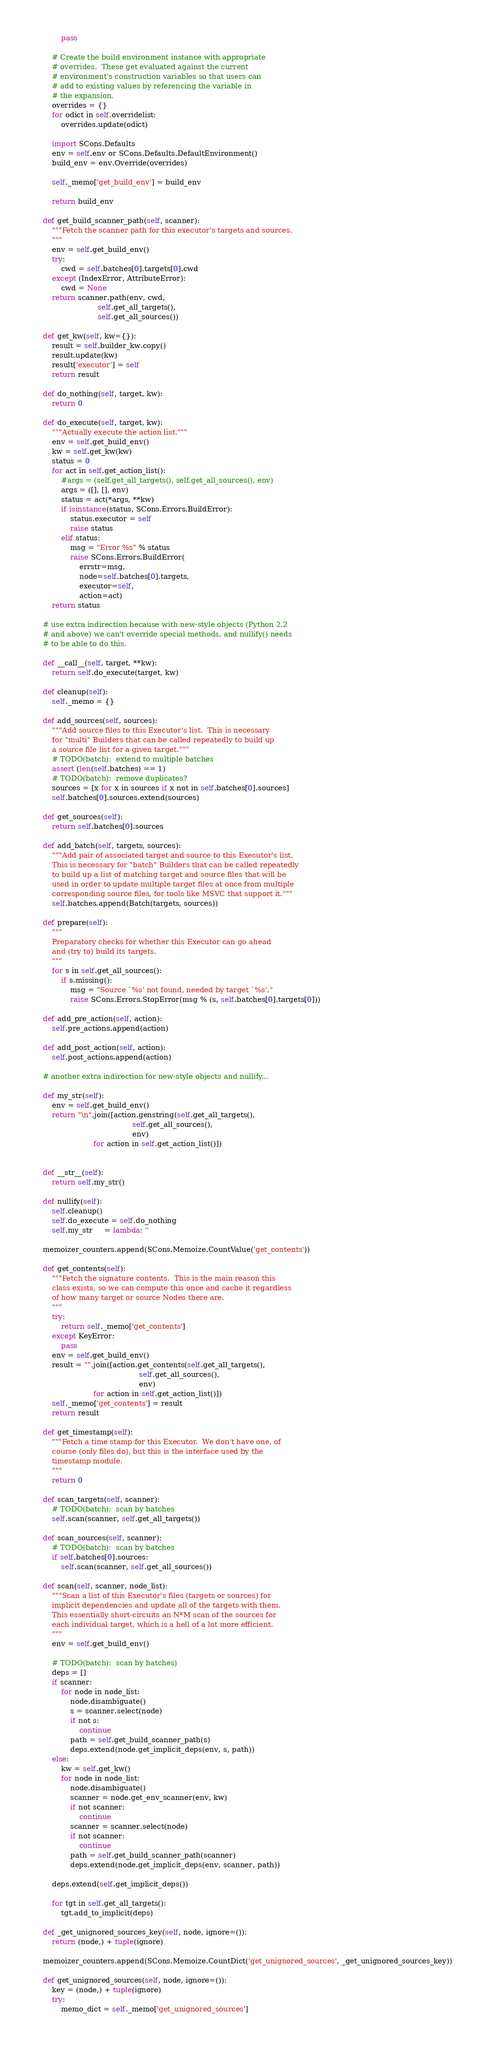<code> <loc_0><loc_0><loc_500><loc_500><_Python_>            pass

        # Create the build environment instance with appropriate
        # overrides.  These get evaluated against the current
        # environment's construction variables so that users can
        # add to existing values by referencing the variable in
        # the expansion.
        overrides = {}
        for odict in self.overridelist:
            overrides.update(odict)

        import SCons.Defaults
        env = self.env or SCons.Defaults.DefaultEnvironment()
        build_env = env.Override(overrides)

        self._memo['get_build_env'] = build_env

        return build_env

    def get_build_scanner_path(self, scanner):
        """Fetch the scanner path for this executor's targets and sources.
        """
        env = self.get_build_env()
        try:
            cwd = self.batches[0].targets[0].cwd
        except (IndexError, AttributeError):
            cwd = None
        return scanner.path(env, cwd,
                            self.get_all_targets(),
                            self.get_all_sources())

    def get_kw(self, kw={}):
        result = self.builder_kw.copy()
        result.update(kw)
        result['executor'] = self
        return result

    def do_nothing(self, target, kw):
        return 0

    def do_execute(self, target, kw):
        """Actually execute the action list."""
        env = self.get_build_env()
        kw = self.get_kw(kw)
        status = 0
        for act in self.get_action_list():
            #args = (self.get_all_targets(), self.get_all_sources(), env)
            args = ([], [], env)
            status = act(*args, **kw)
            if isinstance(status, SCons.Errors.BuildError):
                status.executor = self
                raise status
            elif status:
                msg = "Error %s" % status
                raise SCons.Errors.BuildError(
                    errstr=msg, 
                    node=self.batches[0].targets,
                    executor=self, 
                    action=act)
        return status

    # use extra indirection because with new-style objects (Python 2.2
    # and above) we can't override special methods, and nullify() needs
    # to be able to do this.

    def __call__(self, target, **kw):
        return self.do_execute(target, kw)

    def cleanup(self):
        self._memo = {}

    def add_sources(self, sources):
        """Add source files to this Executor's list.  This is necessary
        for "multi" Builders that can be called repeatedly to build up
        a source file list for a given target."""
        # TODO(batch):  extend to multiple batches
        assert (len(self.batches) == 1)
        # TODO(batch):  remove duplicates?
        sources = [x for x in sources if x not in self.batches[0].sources]
        self.batches[0].sources.extend(sources)

    def get_sources(self):
        return self.batches[0].sources

    def add_batch(self, targets, sources):
        """Add pair of associated target and source to this Executor's list.
        This is necessary for "batch" Builders that can be called repeatedly
        to build up a list of matching target and source files that will be
        used in order to update multiple target files at once from multiple
        corresponding source files, for tools like MSVC that support it."""
        self.batches.append(Batch(targets, sources))

    def prepare(self):
        """
        Preparatory checks for whether this Executor can go ahead
        and (try to) build its targets.
        """
        for s in self.get_all_sources():
            if s.missing():
                msg = "Source `%s' not found, needed by target `%s'."
                raise SCons.Errors.StopError(msg % (s, self.batches[0].targets[0]))

    def add_pre_action(self, action):
        self.pre_actions.append(action)

    def add_post_action(self, action):
        self.post_actions.append(action)

    # another extra indirection for new-style objects and nullify...

    def my_str(self):
        env = self.get_build_env()
        return "\n".join([action.genstring(self.get_all_targets(),
                                           self.get_all_sources(),
                                           env)
                          for action in self.get_action_list()])


    def __str__(self):
        return self.my_str()

    def nullify(self):
        self.cleanup()
        self.do_execute = self.do_nothing
        self.my_str     = lambda: ''

    memoizer_counters.append(SCons.Memoize.CountValue('get_contents'))

    def get_contents(self):
        """Fetch the signature contents.  This is the main reason this
        class exists, so we can compute this once and cache it regardless
        of how many target or source Nodes there are.
        """
        try:
            return self._memo['get_contents']
        except KeyError:
            pass
        env = self.get_build_env()
        result = "".join([action.get_contents(self.get_all_targets(),
                                              self.get_all_sources(),
                                              env)
                          for action in self.get_action_list()])
        self._memo['get_contents'] = result
        return result

    def get_timestamp(self):
        """Fetch a time stamp for this Executor.  We don't have one, of
        course (only files do), but this is the interface used by the
        timestamp module.
        """
        return 0

    def scan_targets(self, scanner):
        # TODO(batch):  scan by batches
        self.scan(scanner, self.get_all_targets())

    def scan_sources(self, scanner):
        # TODO(batch):  scan by batches
        if self.batches[0].sources:
            self.scan(scanner, self.get_all_sources())

    def scan(self, scanner, node_list):
        """Scan a list of this Executor's files (targets or sources) for
        implicit dependencies and update all of the targets with them.
        This essentially short-circuits an N*M scan of the sources for
        each individual target, which is a hell of a lot more efficient.
        """
        env = self.get_build_env()

        # TODO(batch):  scan by batches)
        deps = []
        if scanner:
            for node in node_list:
                node.disambiguate()
                s = scanner.select(node)
                if not s:
                    continue
                path = self.get_build_scanner_path(s)
                deps.extend(node.get_implicit_deps(env, s, path))
        else:
            kw = self.get_kw()
            for node in node_list:
                node.disambiguate()
                scanner = node.get_env_scanner(env, kw)
                if not scanner:
                    continue
                scanner = scanner.select(node)
                if not scanner:
                    continue
                path = self.get_build_scanner_path(scanner)
                deps.extend(node.get_implicit_deps(env, scanner, path))

        deps.extend(self.get_implicit_deps())

        for tgt in self.get_all_targets():
            tgt.add_to_implicit(deps)

    def _get_unignored_sources_key(self, node, ignore=()):
        return (node,) + tuple(ignore)

    memoizer_counters.append(SCons.Memoize.CountDict('get_unignored_sources', _get_unignored_sources_key))

    def get_unignored_sources(self, node, ignore=()):
        key = (node,) + tuple(ignore)
        try:
            memo_dict = self._memo['get_unignored_sources']</code> 